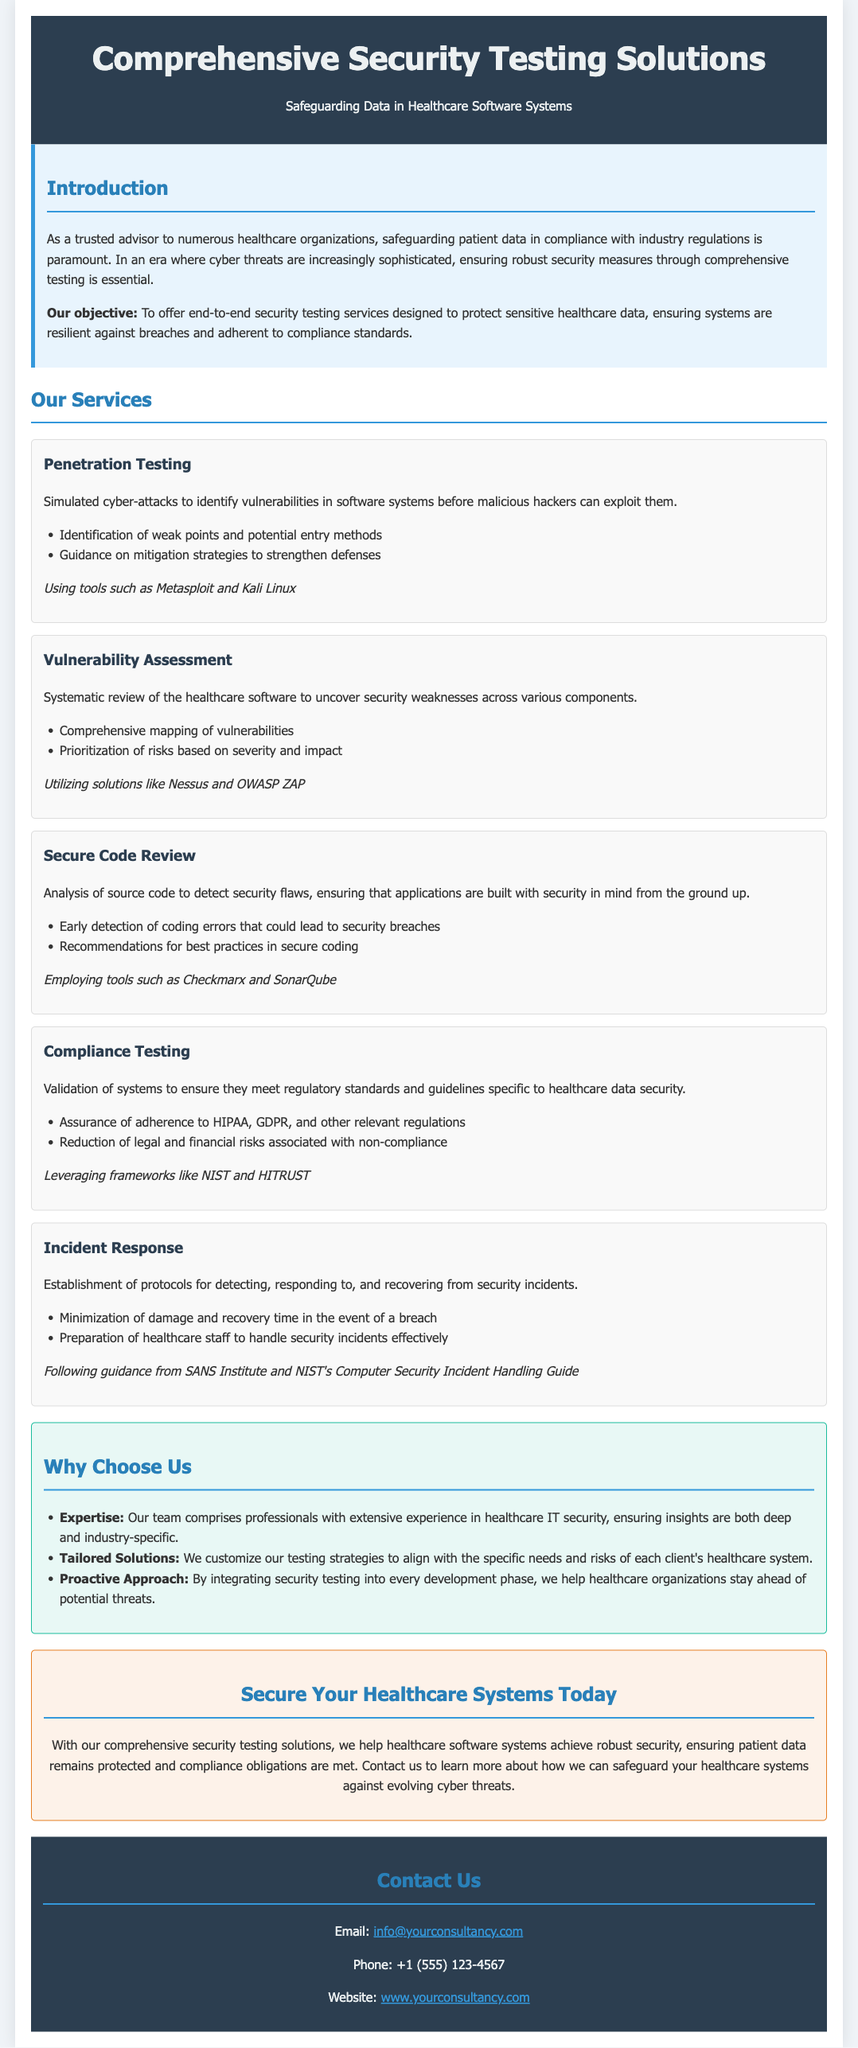What is the main objective of the proposal? The objective is to offer end-to-end security testing services designed to protect sensitive healthcare data.
Answer: to offer end-to-end security testing services designed to protect sensitive healthcare data What regulatory standards are mentioned in the compliance testing service? The proposal states that the compliance testing ensures adherence to HIPAA, GDPR, and other relevant regulations.
Answer: HIPAA, GDPR What tools are used for penetration testing? The document specifies tools used in penetration testing as Metasploit and Kali Linux.
Answer: Metasploit and Kali Linux What is the purpose of incident response services? Incident response services are aimed at detecting, responding to, and recovering from security incidents.
Answer: detecting, responding to, and recovering from security incidents How many services are outlined in the proposal? The proposal outlines five services for comprehensive security testing solutions.
Answer: five What is emphasized under "Why Choose Us"? The proposal emphasizes expertise, tailored solutions, and a proactive approach as key selling points.
Answer: expertise, tailored solutions, proactive approach What does the conclusion suggest regarding securing healthcare systems? The conclusion states to contact them to learn more about safeguarding healthcare systems against cyber threats.
Answer: contact us to learn more about safeguarding healthcare systems against cyber threats What is the contact email provided in the document? The proposal provides an email for contact purposes which is info@yourconsultancy.com.
Answer: info@yourconsultancy.com 